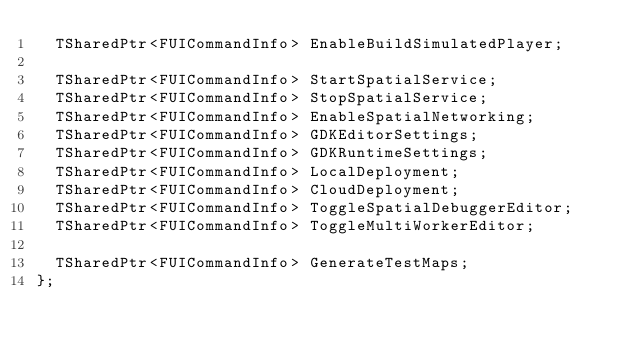<code> <loc_0><loc_0><loc_500><loc_500><_C_>	TSharedPtr<FUICommandInfo> EnableBuildSimulatedPlayer;

	TSharedPtr<FUICommandInfo> StartSpatialService;
	TSharedPtr<FUICommandInfo> StopSpatialService;
	TSharedPtr<FUICommandInfo> EnableSpatialNetworking;
	TSharedPtr<FUICommandInfo> GDKEditorSettings;
	TSharedPtr<FUICommandInfo> GDKRuntimeSettings;
	TSharedPtr<FUICommandInfo> LocalDeployment;
	TSharedPtr<FUICommandInfo> CloudDeployment;
	TSharedPtr<FUICommandInfo> ToggleSpatialDebuggerEditor;
	TSharedPtr<FUICommandInfo> ToggleMultiWorkerEditor;

	TSharedPtr<FUICommandInfo> GenerateTestMaps;
};
</code> 